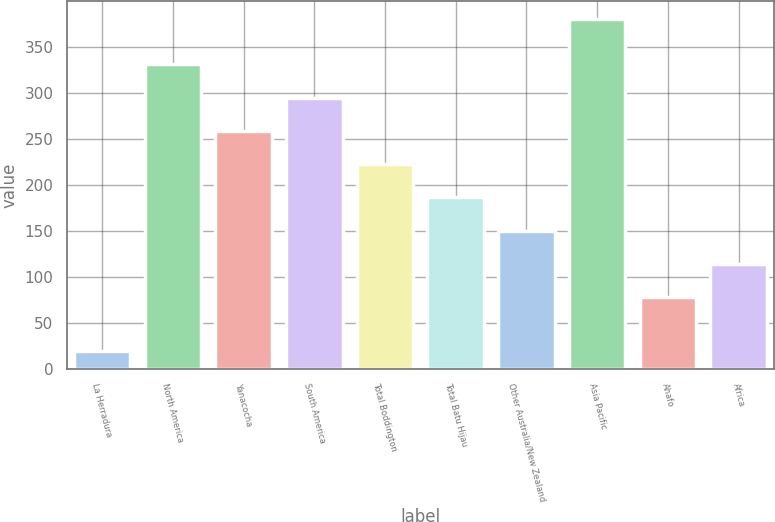Convert chart. <chart><loc_0><loc_0><loc_500><loc_500><bar_chart><fcel>La Herradura<fcel>North America<fcel>Yanacocha<fcel>South America<fcel>Total Boddington<fcel>Total Batu Hijau<fcel>Other Australia/New Zealand<fcel>Asia Pacific<fcel>Ahafo<fcel>Africa<nl><fcel>19<fcel>330.7<fcel>258.5<fcel>294.6<fcel>222.4<fcel>186.3<fcel>150.2<fcel>380<fcel>78<fcel>114.1<nl></chart> 